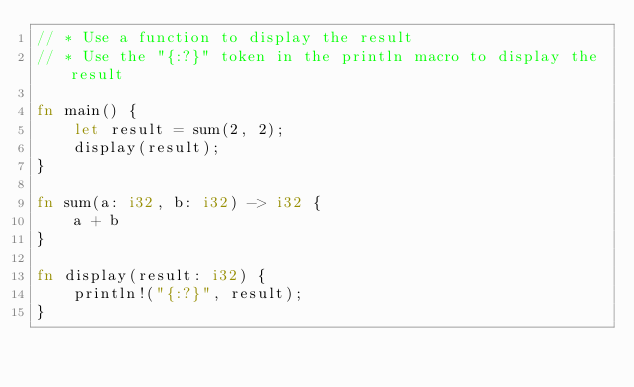Convert code to text. <code><loc_0><loc_0><loc_500><loc_500><_Rust_>// * Use a function to display the result
// * Use the "{:?}" token in the println macro to display the result

fn main() {
    let result = sum(2, 2);
    display(result);
}

fn sum(a: i32, b: i32) -> i32 {
    a + b
}

fn display(result: i32) {
    println!("{:?}", result);
}</code> 